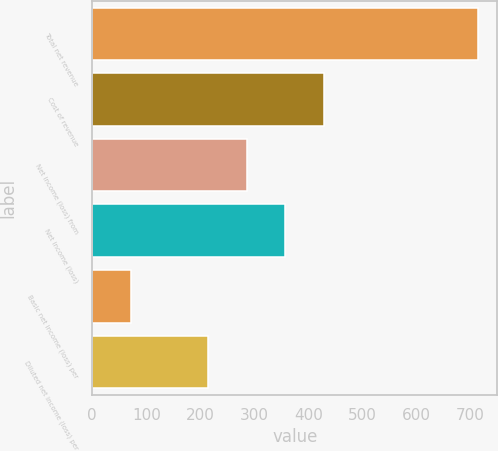Convert chart to OTSL. <chart><loc_0><loc_0><loc_500><loc_500><bar_chart><fcel>Total net revenue<fcel>Cost of revenue<fcel>Net income (loss) from<fcel>Net income (loss)<fcel>Basic net income (loss) per<fcel>Diluted net income (loss) per<nl><fcel>714<fcel>428.44<fcel>285.66<fcel>357.05<fcel>71.49<fcel>214.27<nl></chart> 